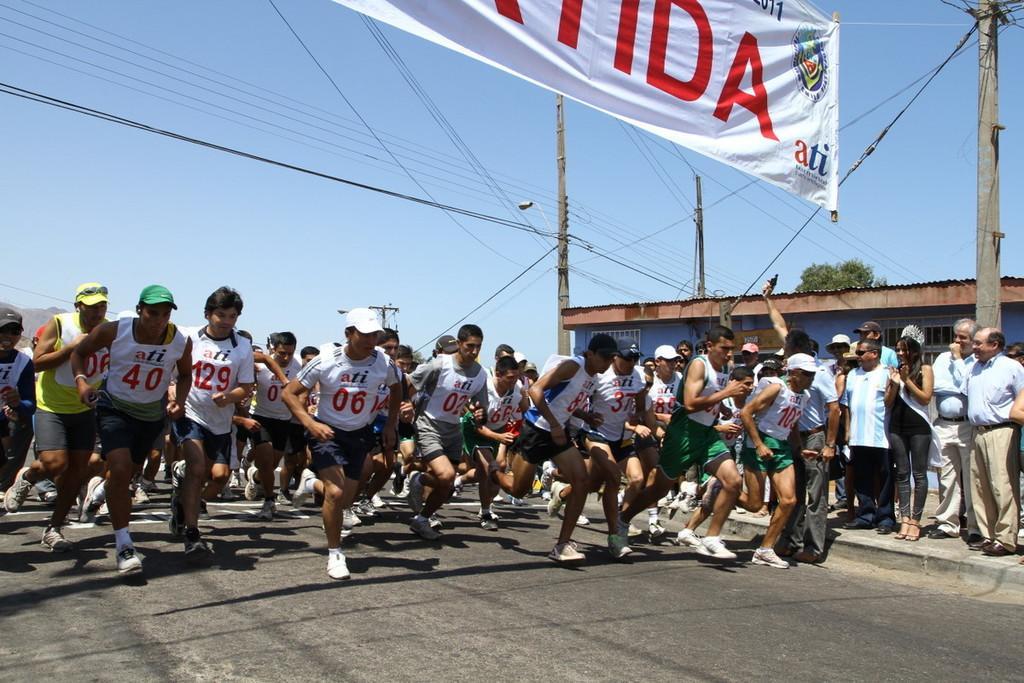How would you summarize this image in a sentence or two? In this picture there is a group of men running in the marathon. Behind we can see small house, electric pole and cables. On the top there is a white banner. 